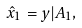Convert formula to latex. <formula><loc_0><loc_0><loc_500><loc_500>\hat { x } _ { 1 } = y | A _ { 1 } ,</formula> 